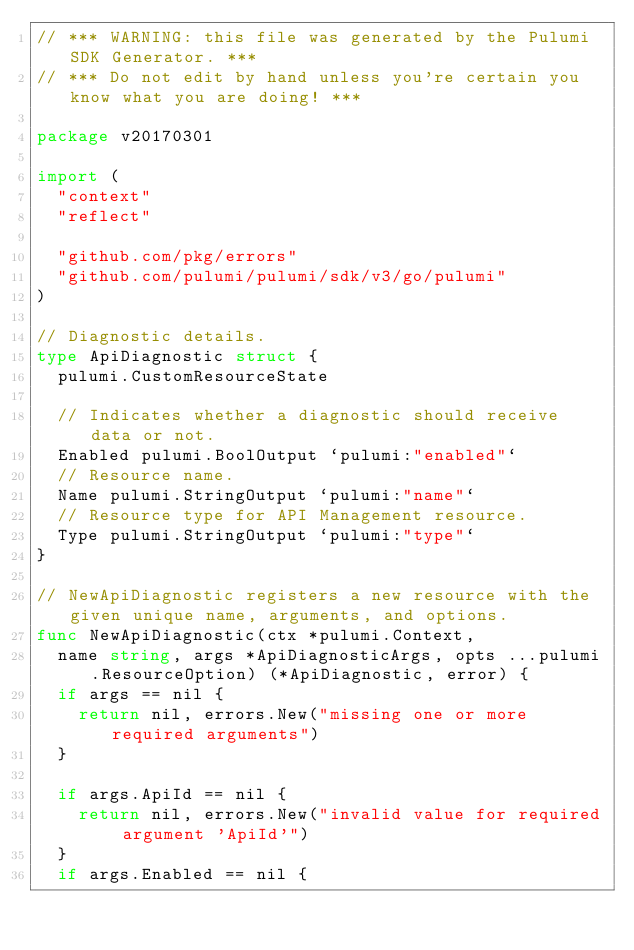Convert code to text. <code><loc_0><loc_0><loc_500><loc_500><_Go_>// *** WARNING: this file was generated by the Pulumi SDK Generator. ***
// *** Do not edit by hand unless you're certain you know what you are doing! ***

package v20170301

import (
	"context"
	"reflect"

	"github.com/pkg/errors"
	"github.com/pulumi/pulumi/sdk/v3/go/pulumi"
)

// Diagnostic details.
type ApiDiagnostic struct {
	pulumi.CustomResourceState

	// Indicates whether a diagnostic should receive data or not.
	Enabled pulumi.BoolOutput `pulumi:"enabled"`
	// Resource name.
	Name pulumi.StringOutput `pulumi:"name"`
	// Resource type for API Management resource.
	Type pulumi.StringOutput `pulumi:"type"`
}

// NewApiDiagnostic registers a new resource with the given unique name, arguments, and options.
func NewApiDiagnostic(ctx *pulumi.Context,
	name string, args *ApiDiagnosticArgs, opts ...pulumi.ResourceOption) (*ApiDiagnostic, error) {
	if args == nil {
		return nil, errors.New("missing one or more required arguments")
	}

	if args.ApiId == nil {
		return nil, errors.New("invalid value for required argument 'ApiId'")
	}
	if args.Enabled == nil {</code> 